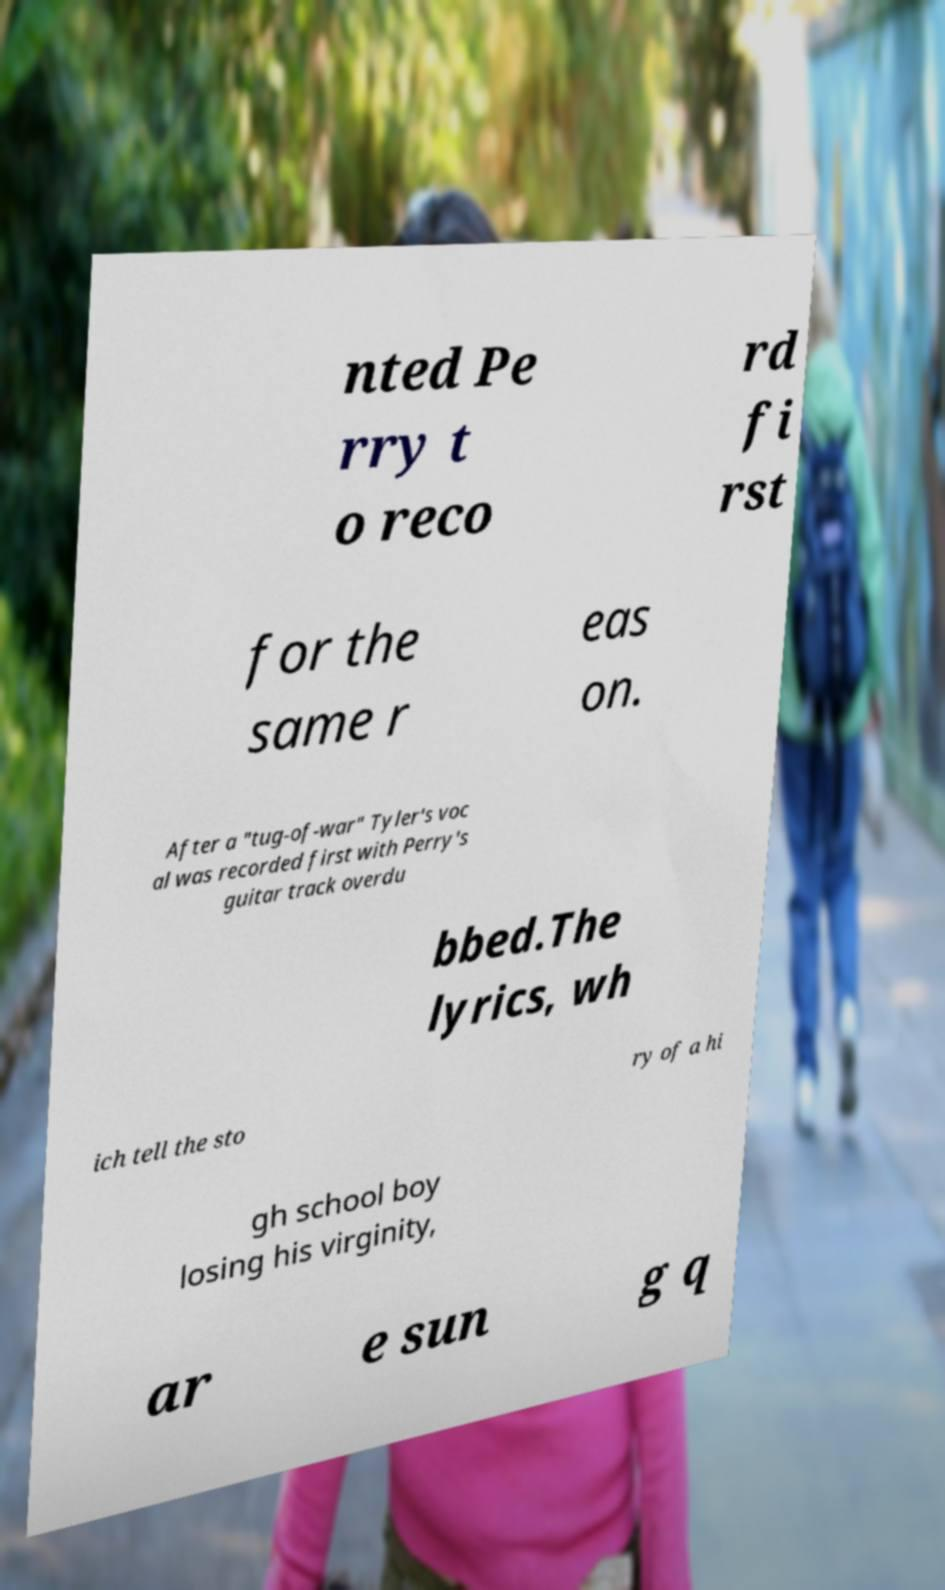I need the written content from this picture converted into text. Can you do that? nted Pe rry t o reco rd fi rst for the same r eas on. After a "tug-of-war" Tyler's voc al was recorded first with Perry's guitar track overdu bbed.The lyrics, wh ich tell the sto ry of a hi gh school boy losing his virginity, ar e sun g q 